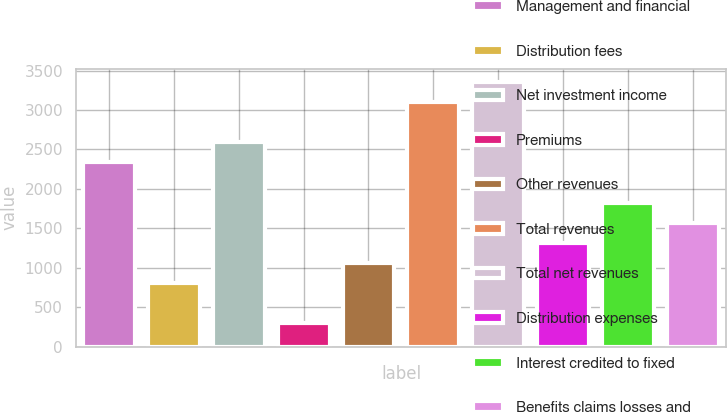Convert chart to OTSL. <chart><loc_0><loc_0><loc_500><loc_500><bar_chart><fcel>Management and financial<fcel>Distribution fees<fcel>Net investment income<fcel>Premiums<fcel>Other revenues<fcel>Total revenues<fcel>Total net revenues<fcel>Distribution expenses<fcel>Interest credited to fixed<fcel>Benefits claims losses and<nl><fcel>2335.7<fcel>803.9<fcel>2591<fcel>293.3<fcel>1059.2<fcel>3101.6<fcel>3356.9<fcel>1314.5<fcel>1825.1<fcel>1569.8<nl></chart> 